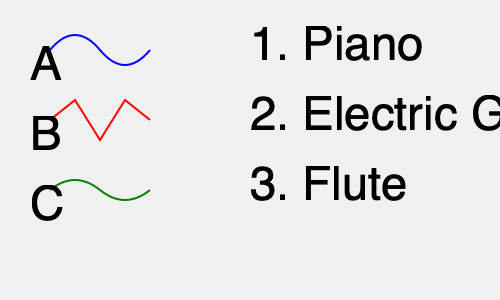Match the audio waveforms (A, B, C) to their corresponding musical instruments (1, 2, 3). Which combination is correct? To match the audio waveforms to their corresponding musical instruments, we need to analyze the characteristics of each waveform and relate them to the typical sound production of each instrument:

1. Waveform A: This shows a smooth, rounded shape with gradual transitions. This type of waveform is characteristic of instruments with a sustained, mellow tone. The piano produces such a waveform due to its strings and resonant body, which create a rich, harmonic sound with a smooth attack and decay.

2. Waveform B: This displays a sharp, jagged pattern with abrupt changes in amplitude. This is typical of instruments with a strong attack and complex harmonics. The electric guitar, especially when distorted or overdriven, produces such a waveform due to its amplified string vibrations and electronic processing.

3. Waveform C: This shows a more sinusoidal pattern with a gentle, repeating curve. This type of waveform is associated with instruments that produce a pure, simple tone with fewer harmonics. The flute, being a wind instrument with a relatively simple sound production mechanism, typically generates such a waveform.

Therefore, the correct matching is:
A - 1 (Piano)
B - 2 (Electric Guitar)
C - 3 (Flute)
Answer: A1, B2, C3 